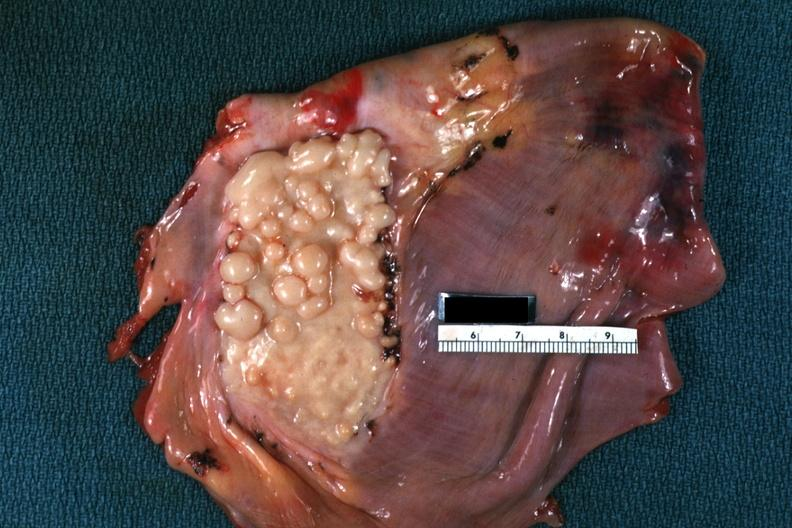s muscle present?
Answer the question using a single word or phrase. Yes 